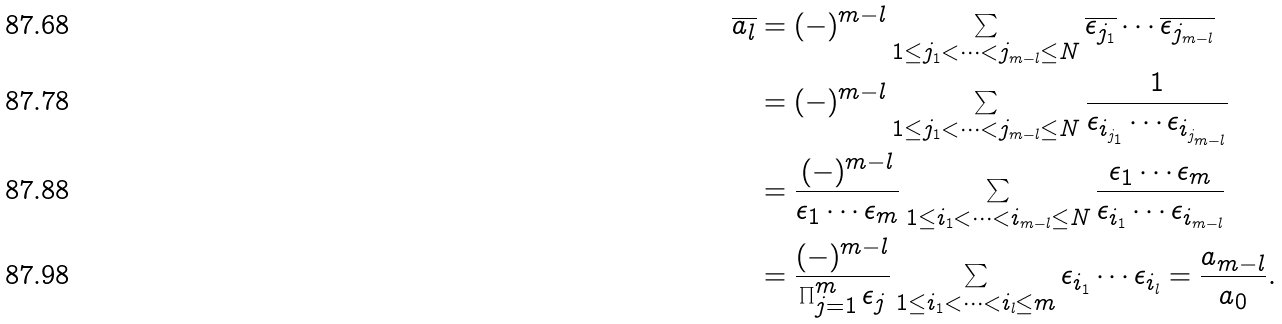<formula> <loc_0><loc_0><loc_500><loc_500>\overline { a _ { l } } & = ( - ) ^ { m - l } \sum _ { 1 \leq j _ { 1 } < \cdots < j _ { m - l } \leq N } \overline { \epsilon _ { j _ { 1 } } } \cdots \overline { \epsilon _ { j _ { m - l } } } \\ \quad & = ( - ) ^ { m - l } \sum _ { 1 \leq j _ { 1 } < \cdots < j _ { m - l } \leq N } \frac { 1 } { \epsilon _ { i _ { j _ { 1 } } } \cdots { \epsilon _ { i _ { j _ { m - l } } } } } \\ \ & = \frac { ( - ) ^ { m - l } } { \epsilon _ { 1 } \cdots \epsilon _ { m } } \sum _ { 1 \leq i _ { 1 } < \cdots < i _ { m - l } \leq N } \frac { \epsilon _ { 1 } \cdots \epsilon _ { m } } { \epsilon _ { i _ { 1 } } \cdots { \epsilon _ { i _ { m - l } } } } \\ \ & = \frac { ( - ) ^ { m - l } } { \prod _ { j = 1 } ^ { m } \epsilon _ { j } } \sum _ { 1 \leq i _ { 1 } < \cdots < i _ { l } \leq m } \epsilon _ { i _ { 1 } } \cdots { \epsilon _ { i _ { l } } } = \frac { a _ { m - l } } { a _ { 0 } } .</formula> 